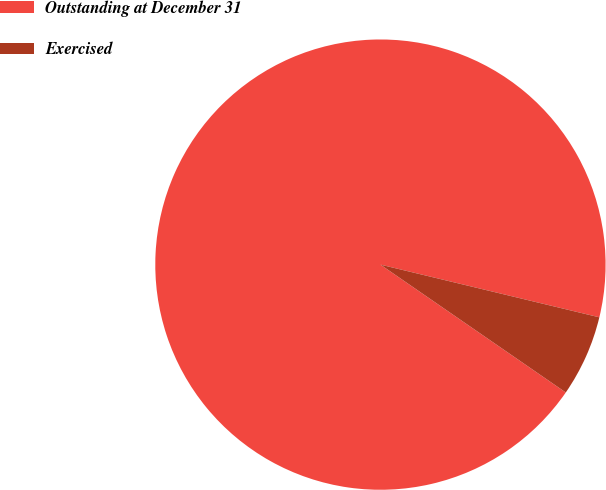<chart> <loc_0><loc_0><loc_500><loc_500><pie_chart><fcel>Outstanding at December 31<fcel>Exercised<nl><fcel>94.15%<fcel>5.85%<nl></chart> 